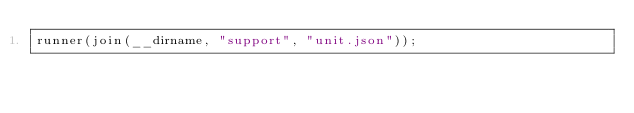Convert code to text. <code><loc_0><loc_0><loc_500><loc_500><_TypeScript_>runner(join(__dirname, "support", "unit.json"));
</code> 